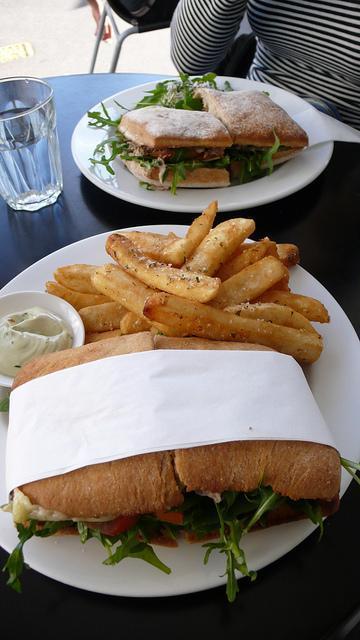How many sandwiches can you see?
Give a very brief answer. 3. How many kites are in the image?
Give a very brief answer. 0. 